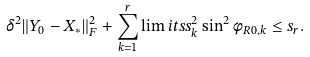<formula> <loc_0><loc_0><loc_500><loc_500>\delta ^ { 2 } \| Y _ { 0 } - X _ { * } \| _ { F } ^ { 2 } + \sum _ { k = 1 } ^ { r } \lim i t s s _ { k } ^ { 2 } \sin ^ { 2 } \phi _ { R 0 , k } \leq s _ { r } .</formula> 